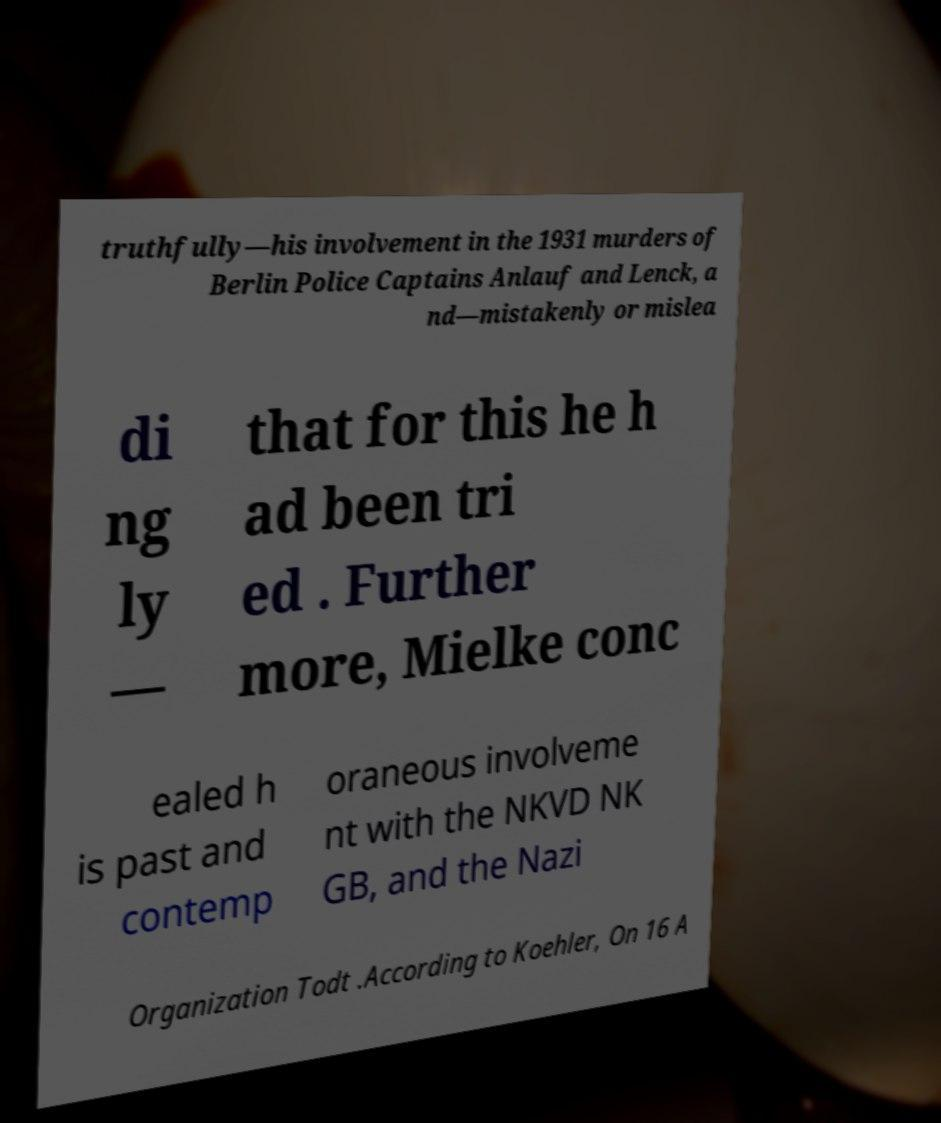What messages or text are displayed in this image? I need them in a readable, typed format. truthfully—his involvement in the 1931 murders of Berlin Police Captains Anlauf and Lenck, a nd—mistakenly or mislea di ng ly — that for this he h ad been tri ed . Further more, Mielke conc ealed h is past and contemp oraneous involveme nt with the NKVD NK GB, and the Nazi Organization Todt .According to Koehler, On 16 A 